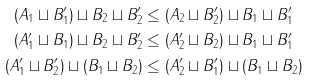<formula> <loc_0><loc_0><loc_500><loc_500>( A _ { 1 } \sqcup B _ { 1 } ^ { \prime } ) \sqcup B _ { 2 } \sqcup B _ { 2 } ^ { \prime } & \leq ( A _ { 2 } \sqcup B _ { 2 } ^ { \prime } ) \sqcup B _ { 1 } \sqcup B _ { 1 } ^ { \prime } \\ ( A _ { 1 } ^ { \prime } \sqcup B _ { 1 } ) \sqcup B _ { 2 } \sqcup B _ { 2 } ^ { \prime } & \leq ( A _ { 2 } ^ { \prime } \sqcup B _ { 2 } ) \sqcup B _ { 1 } \sqcup B _ { 1 } ^ { \prime } \\ ( A _ { 1 } ^ { \prime } \sqcup B ^ { \prime } _ { 2 } ) \sqcup ( B _ { 1 } \sqcup B _ { 2 } ) & \leq ( A _ { 2 } ^ { \prime } \sqcup B _ { 1 } ^ { \prime } ) \sqcup ( B _ { 1 } \sqcup B _ { 2 } )</formula> 